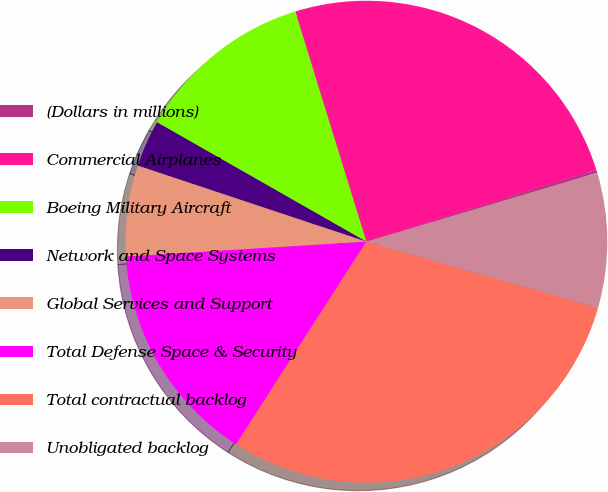Convert chart. <chart><loc_0><loc_0><loc_500><loc_500><pie_chart><fcel>(Dollars in millions)<fcel>Commercial Airplanes<fcel>Boeing Military Aircraft<fcel>Network and Space Systems<fcel>Global Services and Support<fcel>Total Defense Space & Security<fcel>Total contractual backlog<fcel>Unobligated backlog<nl><fcel>0.2%<fcel>24.95%<fcel>11.98%<fcel>3.14%<fcel>6.09%<fcel>14.93%<fcel>29.67%<fcel>9.04%<nl></chart> 